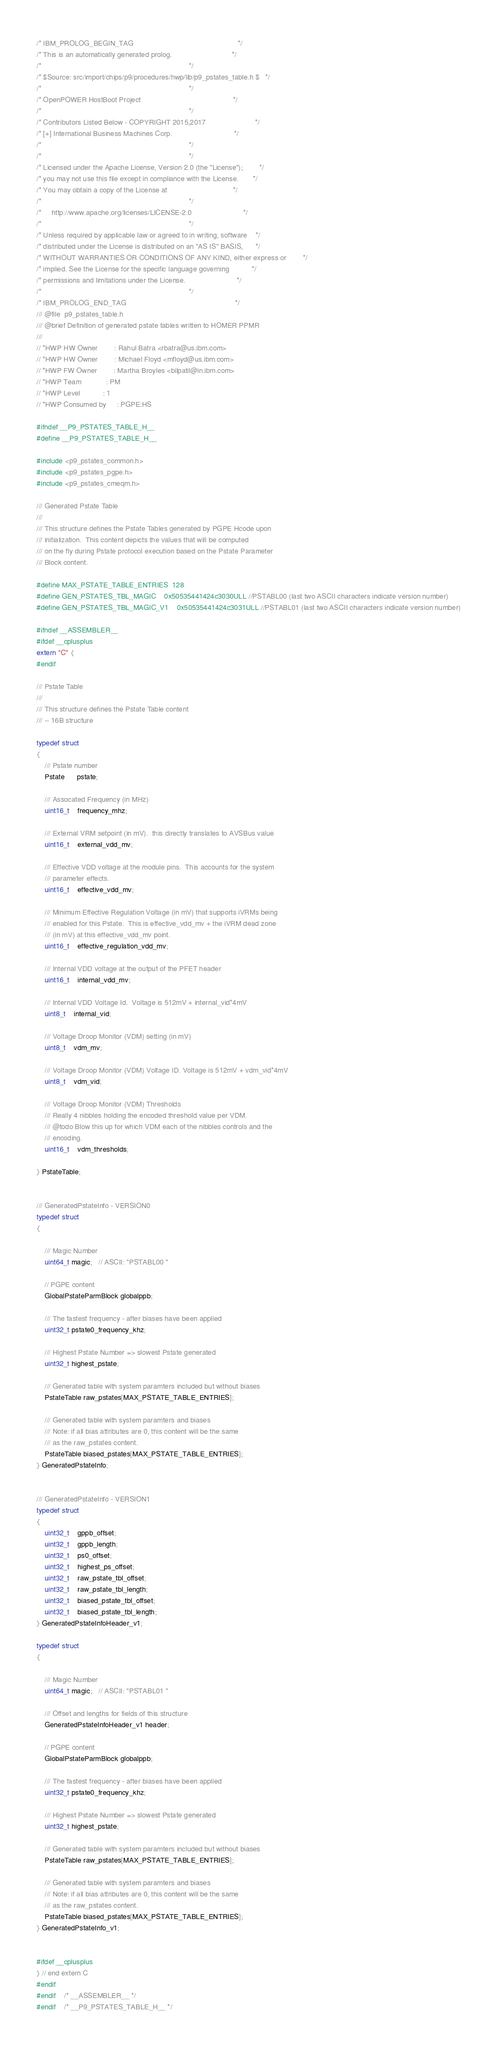<code> <loc_0><loc_0><loc_500><loc_500><_C_>/* IBM_PROLOG_BEGIN_TAG                                                   */
/* This is an automatically generated prolog.                             */
/*                                                                        */
/* $Source: src/import/chips/p9/procedures/hwp/lib/p9_pstates_table.h $   */
/*                                                                        */
/* OpenPOWER HostBoot Project                                             */
/*                                                                        */
/* Contributors Listed Below - COPYRIGHT 2015,2017                        */
/* [+] International Business Machines Corp.                              */
/*                                                                        */
/*                                                                        */
/* Licensed under the Apache License, Version 2.0 (the "License");        */
/* you may not use this file except in compliance with the License.       */
/* You may obtain a copy of the License at                                */
/*                                                                        */
/*     http://www.apache.org/licenses/LICENSE-2.0                         */
/*                                                                        */
/* Unless required by applicable law or agreed to in writing, software    */
/* distributed under the License is distributed on an "AS IS" BASIS,      */
/* WITHOUT WARRANTIES OR CONDITIONS OF ANY KIND, either express or        */
/* implied. See the License for the specific language governing           */
/* permissions and limitations under the License.                         */
/*                                                                        */
/* IBM_PROLOG_END_TAG                                                     */
/// @file  p9_pstates_table.h
/// @brief Definition of generated pstate tables written to HOMER PPMR
///
// *HWP HW Owner        : Rahul Batra <rbatra@us.ibm.com>
// *HWP HW Owner        : Michael Floyd <mfloyd@us.ibm.com>
// *HWP FW Owner        : Martha Broyles <bilpatil@in.ibm.com>
// *HWP Team            : PM
// *HWP Level           : 1
// *HWP Consumed by     : PGPE:HS

#ifndef __P9_PSTATES_TABLE_H__
#define __P9_PSTATES_TABLE_H__

#include <p9_pstates_common.h>
#include <p9_pstates_pgpe.h>
#include <p9_pstates_cmeqm.h>

/// Generated Pstate Table
///
/// This structure defines the Pstate Tables generated by PGPE Hcode upon
/// initialization.  This content depicts the values that will be computed
/// on the fly during Pstate protocol execution based on the Pstate Parameter
/// Block content.

#define MAX_PSTATE_TABLE_ENTRIES  128
#define GEN_PSTATES_TBL_MAGIC    0x50535441424c3030ULL //PSTABL00 (last two ASCII characters indicate version number)
#define GEN_PSTATES_TBL_MAGIC_V1    0x50535441424c3031ULL //PSTABL01 (last two ASCII characters indicate version number)

#ifndef __ASSEMBLER__
#ifdef __cplusplus
extern "C" {
#endif

/// Pstate Table
///
/// This structure defines the Pstate Table content
/// -- 16B structure

typedef struct
{
    /// Pstate number
    Pstate      pstate;

    /// Assocated Frequency (in MHz)
    uint16_t    frequency_mhz;

    /// External VRM setpoint (in mV).  this directly translates to AVSBus value
    uint16_t    external_vdd_mv;

    /// Effective VDD voltage at the module pins.  This accounts for the system
    /// parameter effects.
    uint16_t    effective_vdd_mv;

    /// Minimum Effective Regulation Voltage (in mV) that supports iVRMs being
    /// enabled for this Pstate.  This is effective_vdd_mv + the iVRM dead zone
    /// (in mV) at this effective_vdd_mv point.
    uint16_t    effective_regulation_vdd_mv;

    /// Internal VDD voltage at the output of the PFET header
    uint16_t    internal_vdd_mv;

    /// Internal VDD Voltage Id.  Voltage is 512mV + internal_vid*4mV
    uint8_t    internal_vid;

    /// Voltage Droop Monitor (VDM) setting (in mV)
    uint8_t    vdm_mv;

    /// Voltage Droop Monitor (VDM) Voltage ID. Voltage is 512mV + vdm_vid*4mV
    uint8_t    vdm_vid;

    /// Voltage Droop Monitor (VDM) Thresholds
    /// Really 4 nibbles holding the encoded threshold value per VDM.
    /// @todo Blow this up for which VDM each of the nibbles controls and the
    /// encoding.
    uint16_t    vdm_thresholds;

} PstateTable;


/// GeneratedPstateInfo - VERSION0
typedef struct
{

    /// Magic Number
    uint64_t magic;   // ASCII: "PSTABL00 "

    // PGPE content
    GlobalPstateParmBlock globalppb;

    /// The fastest frequency - after biases have been applied
    uint32_t pstate0_frequency_khz;

    /// Highest Pstate Number => slowest Pstate generated
    uint32_t highest_pstate;

    /// Generated table with system paramters included but without biases
    PstateTable raw_pstates[MAX_PSTATE_TABLE_ENTRIES];

    /// Generated table with system paramters and biases
    /// Note: if all bias attributes are 0, this content will be the same
    /// as the raw_pstates content.
    PstateTable biased_pstates[MAX_PSTATE_TABLE_ENTRIES];
} GeneratedPstateInfo;


/// GeneratedPstateInfo - VERSION1
typedef struct
{
    uint32_t    gppb_offset;
    uint32_t    gppb_length;
    uint32_t    ps0_offset;
    uint32_t    highest_ps_offset;
    uint32_t    raw_pstate_tbl_offset;
    uint32_t    raw_pstate_tbl_length;
    uint32_t    biased_pstate_tbl_offset;
    uint32_t    biased_pstate_tbl_length;
} GeneratedPstateInfoHeader_v1;

typedef struct
{

    /// Magic Number
    uint64_t magic;   // ASCII: "PSTABL01 "

    /// Offset and lengths for fields of this structure
    GeneratedPstateInfoHeader_v1 header;

    // PGPE content
    GlobalPstateParmBlock globalppb;

    /// The fastest frequency - after biases have been applied
    uint32_t pstate0_frequency_khz;

    /// Highest Pstate Number => slowest Pstate generated
    uint32_t highest_pstate;

    /// Generated table with system paramters included but without biases
    PstateTable raw_pstates[MAX_PSTATE_TABLE_ENTRIES];

    /// Generated table with system paramters and biases
    /// Note: if all bias attributes are 0, this content will be the same
    /// as the raw_pstates content.
    PstateTable biased_pstates[MAX_PSTATE_TABLE_ENTRIES];
} GeneratedPstateInfo_v1;


#ifdef __cplusplus
} // end extern C
#endif
#endif    /* __ASSEMBLER__ */
#endif    /* __P9_PSTATES_TABLE_H__ */
</code> 